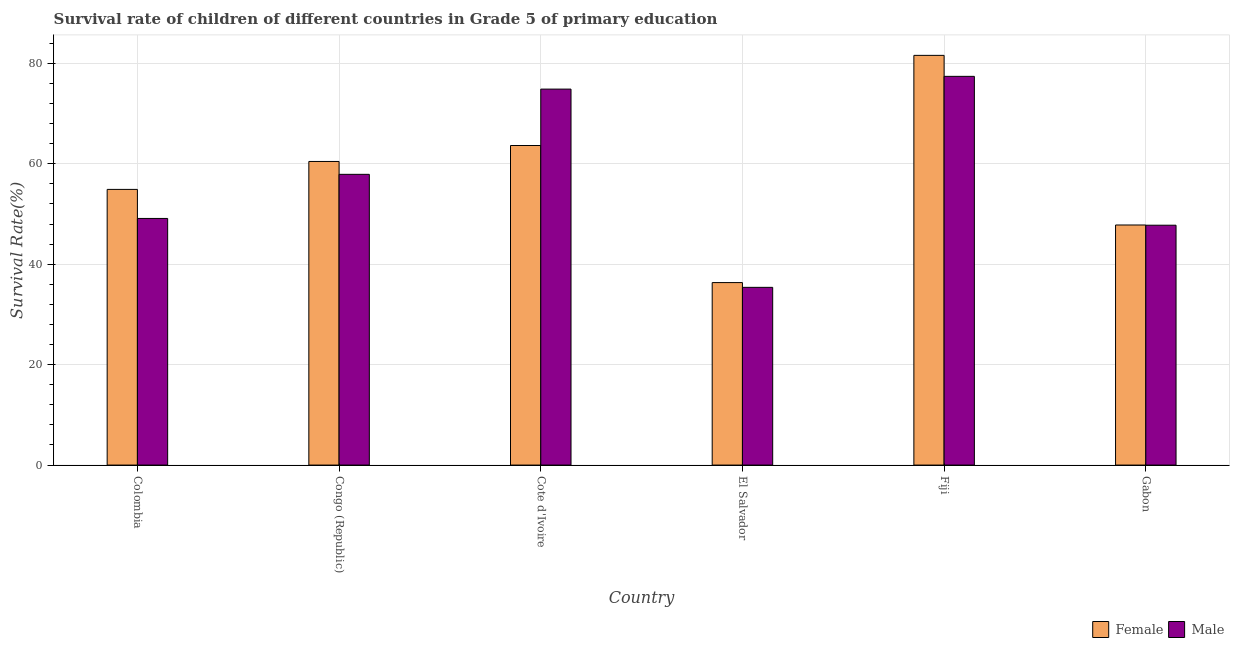How many groups of bars are there?
Provide a succinct answer. 6. Are the number of bars on each tick of the X-axis equal?
Make the answer very short. Yes. How many bars are there on the 4th tick from the left?
Ensure brevity in your answer.  2. What is the label of the 2nd group of bars from the left?
Your response must be concise. Congo (Republic). What is the survival rate of female students in primary education in Fiji?
Your answer should be very brief. 81.6. Across all countries, what is the maximum survival rate of female students in primary education?
Provide a succinct answer. 81.6. Across all countries, what is the minimum survival rate of female students in primary education?
Give a very brief answer. 36.35. In which country was the survival rate of male students in primary education maximum?
Your response must be concise. Fiji. In which country was the survival rate of female students in primary education minimum?
Your answer should be very brief. El Salvador. What is the total survival rate of male students in primary education in the graph?
Your response must be concise. 342.5. What is the difference between the survival rate of female students in primary education in Congo (Republic) and that in El Salvador?
Provide a short and direct response. 24.12. What is the difference between the survival rate of female students in primary education in Fiji and the survival rate of male students in primary education in Colombia?
Your response must be concise. 32.48. What is the average survival rate of male students in primary education per country?
Your response must be concise. 57.08. What is the difference between the survival rate of male students in primary education and survival rate of female students in primary education in Gabon?
Make the answer very short. -0.04. What is the ratio of the survival rate of female students in primary education in El Salvador to that in Fiji?
Keep it short and to the point. 0.45. Is the survival rate of male students in primary education in El Salvador less than that in Fiji?
Provide a short and direct response. Yes. What is the difference between the highest and the second highest survival rate of female students in primary education?
Your answer should be very brief. 17.96. What is the difference between the highest and the lowest survival rate of male students in primary education?
Provide a succinct answer. 42.02. Is the sum of the survival rate of male students in primary education in El Salvador and Gabon greater than the maximum survival rate of female students in primary education across all countries?
Your response must be concise. Yes. What does the 1st bar from the right in Gabon represents?
Your response must be concise. Male. How many bars are there?
Keep it short and to the point. 12. Are all the bars in the graph horizontal?
Keep it short and to the point. No. How many countries are there in the graph?
Give a very brief answer. 6. Are the values on the major ticks of Y-axis written in scientific E-notation?
Provide a succinct answer. No. Where does the legend appear in the graph?
Offer a terse response. Bottom right. How many legend labels are there?
Keep it short and to the point. 2. What is the title of the graph?
Ensure brevity in your answer.  Survival rate of children of different countries in Grade 5 of primary education. Does "RDB concessional" appear as one of the legend labels in the graph?
Offer a terse response. No. What is the label or title of the X-axis?
Your answer should be compact. Country. What is the label or title of the Y-axis?
Offer a very short reply. Survival Rate(%). What is the Survival Rate(%) of Female in Colombia?
Provide a succinct answer. 54.91. What is the Survival Rate(%) of Male in Colombia?
Give a very brief answer. 49.12. What is the Survival Rate(%) of Female in Congo (Republic)?
Your answer should be compact. 60.47. What is the Survival Rate(%) in Male in Congo (Republic)?
Your answer should be compact. 57.91. What is the Survival Rate(%) of Female in Cote d'Ivoire?
Keep it short and to the point. 63.65. What is the Survival Rate(%) in Male in Cote d'Ivoire?
Keep it short and to the point. 74.88. What is the Survival Rate(%) of Female in El Salvador?
Provide a short and direct response. 36.35. What is the Survival Rate(%) of Male in El Salvador?
Offer a terse response. 35.4. What is the Survival Rate(%) in Female in Fiji?
Your answer should be very brief. 81.6. What is the Survival Rate(%) of Male in Fiji?
Provide a short and direct response. 77.42. What is the Survival Rate(%) in Female in Gabon?
Your answer should be very brief. 47.82. What is the Survival Rate(%) of Male in Gabon?
Your response must be concise. 47.77. Across all countries, what is the maximum Survival Rate(%) in Female?
Your answer should be compact. 81.6. Across all countries, what is the maximum Survival Rate(%) in Male?
Your answer should be compact. 77.42. Across all countries, what is the minimum Survival Rate(%) in Female?
Provide a short and direct response. 36.35. Across all countries, what is the minimum Survival Rate(%) in Male?
Provide a succinct answer. 35.4. What is the total Survival Rate(%) of Female in the graph?
Provide a succinct answer. 344.79. What is the total Survival Rate(%) of Male in the graph?
Provide a short and direct response. 342.5. What is the difference between the Survival Rate(%) of Female in Colombia and that in Congo (Republic)?
Give a very brief answer. -5.56. What is the difference between the Survival Rate(%) in Male in Colombia and that in Congo (Republic)?
Provide a succinct answer. -8.79. What is the difference between the Survival Rate(%) in Female in Colombia and that in Cote d'Ivoire?
Make the answer very short. -8.74. What is the difference between the Survival Rate(%) in Male in Colombia and that in Cote d'Ivoire?
Your answer should be very brief. -25.76. What is the difference between the Survival Rate(%) of Female in Colombia and that in El Salvador?
Offer a very short reply. 18.56. What is the difference between the Survival Rate(%) of Male in Colombia and that in El Salvador?
Ensure brevity in your answer.  13.72. What is the difference between the Survival Rate(%) of Female in Colombia and that in Fiji?
Your answer should be very brief. -26.69. What is the difference between the Survival Rate(%) of Male in Colombia and that in Fiji?
Your answer should be compact. -28.3. What is the difference between the Survival Rate(%) in Female in Colombia and that in Gabon?
Your answer should be very brief. 7.09. What is the difference between the Survival Rate(%) in Male in Colombia and that in Gabon?
Provide a succinct answer. 1.35. What is the difference between the Survival Rate(%) of Female in Congo (Republic) and that in Cote d'Ivoire?
Provide a short and direct response. -3.18. What is the difference between the Survival Rate(%) in Male in Congo (Republic) and that in Cote d'Ivoire?
Provide a short and direct response. -16.97. What is the difference between the Survival Rate(%) in Female in Congo (Republic) and that in El Salvador?
Provide a short and direct response. 24.12. What is the difference between the Survival Rate(%) in Male in Congo (Republic) and that in El Salvador?
Your answer should be very brief. 22.51. What is the difference between the Survival Rate(%) in Female in Congo (Republic) and that in Fiji?
Your answer should be very brief. -21.13. What is the difference between the Survival Rate(%) of Male in Congo (Republic) and that in Fiji?
Offer a very short reply. -19.51. What is the difference between the Survival Rate(%) in Female in Congo (Republic) and that in Gabon?
Provide a short and direct response. 12.65. What is the difference between the Survival Rate(%) in Male in Congo (Republic) and that in Gabon?
Provide a succinct answer. 10.14. What is the difference between the Survival Rate(%) of Female in Cote d'Ivoire and that in El Salvador?
Your answer should be compact. 27.3. What is the difference between the Survival Rate(%) in Male in Cote d'Ivoire and that in El Salvador?
Offer a terse response. 39.48. What is the difference between the Survival Rate(%) in Female in Cote d'Ivoire and that in Fiji?
Make the answer very short. -17.96. What is the difference between the Survival Rate(%) in Male in Cote d'Ivoire and that in Fiji?
Offer a terse response. -2.54. What is the difference between the Survival Rate(%) of Female in Cote d'Ivoire and that in Gabon?
Your answer should be very brief. 15.83. What is the difference between the Survival Rate(%) of Male in Cote d'Ivoire and that in Gabon?
Ensure brevity in your answer.  27.11. What is the difference between the Survival Rate(%) of Female in El Salvador and that in Fiji?
Keep it short and to the point. -45.26. What is the difference between the Survival Rate(%) of Male in El Salvador and that in Fiji?
Offer a terse response. -42.02. What is the difference between the Survival Rate(%) of Female in El Salvador and that in Gabon?
Offer a terse response. -11.47. What is the difference between the Survival Rate(%) of Male in El Salvador and that in Gabon?
Your answer should be compact. -12.37. What is the difference between the Survival Rate(%) of Female in Fiji and that in Gabon?
Make the answer very short. 33.79. What is the difference between the Survival Rate(%) in Male in Fiji and that in Gabon?
Your answer should be very brief. 29.65. What is the difference between the Survival Rate(%) in Female in Colombia and the Survival Rate(%) in Male in Congo (Republic)?
Your answer should be compact. -3. What is the difference between the Survival Rate(%) of Female in Colombia and the Survival Rate(%) of Male in Cote d'Ivoire?
Give a very brief answer. -19.97. What is the difference between the Survival Rate(%) of Female in Colombia and the Survival Rate(%) of Male in El Salvador?
Ensure brevity in your answer.  19.51. What is the difference between the Survival Rate(%) in Female in Colombia and the Survival Rate(%) in Male in Fiji?
Ensure brevity in your answer.  -22.51. What is the difference between the Survival Rate(%) in Female in Colombia and the Survival Rate(%) in Male in Gabon?
Keep it short and to the point. 7.14. What is the difference between the Survival Rate(%) in Female in Congo (Republic) and the Survival Rate(%) in Male in Cote d'Ivoire?
Your answer should be very brief. -14.41. What is the difference between the Survival Rate(%) in Female in Congo (Republic) and the Survival Rate(%) in Male in El Salvador?
Your answer should be very brief. 25.07. What is the difference between the Survival Rate(%) in Female in Congo (Republic) and the Survival Rate(%) in Male in Fiji?
Keep it short and to the point. -16.95. What is the difference between the Survival Rate(%) of Female in Congo (Republic) and the Survival Rate(%) of Male in Gabon?
Provide a succinct answer. 12.7. What is the difference between the Survival Rate(%) of Female in Cote d'Ivoire and the Survival Rate(%) of Male in El Salvador?
Give a very brief answer. 28.25. What is the difference between the Survival Rate(%) in Female in Cote d'Ivoire and the Survival Rate(%) in Male in Fiji?
Offer a terse response. -13.78. What is the difference between the Survival Rate(%) of Female in Cote d'Ivoire and the Survival Rate(%) of Male in Gabon?
Keep it short and to the point. 15.87. What is the difference between the Survival Rate(%) of Female in El Salvador and the Survival Rate(%) of Male in Fiji?
Your answer should be very brief. -41.08. What is the difference between the Survival Rate(%) in Female in El Salvador and the Survival Rate(%) in Male in Gabon?
Ensure brevity in your answer.  -11.43. What is the difference between the Survival Rate(%) of Female in Fiji and the Survival Rate(%) of Male in Gabon?
Offer a terse response. 33.83. What is the average Survival Rate(%) in Female per country?
Your answer should be compact. 57.46. What is the average Survival Rate(%) in Male per country?
Your answer should be very brief. 57.08. What is the difference between the Survival Rate(%) of Female and Survival Rate(%) of Male in Colombia?
Ensure brevity in your answer.  5.79. What is the difference between the Survival Rate(%) of Female and Survival Rate(%) of Male in Congo (Republic)?
Provide a succinct answer. 2.56. What is the difference between the Survival Rate(%) of Female and Survival Rate(%) of Male in Cote d'Ivoire?
Provide a succinct answer. -11.24. What is the difference between the Survival Rate(%) of Female and Survival Rate(%) of Male in El Salvador?
Your answer should be very brief. 0.95. What is the difference between the Survival Rate(%) of Female and Survival Rate(%) of Male in Fiji?
Provide a succinct answer. 4.18. What is the difference between the Survival Rate(%) of Female and Survival Rate(%) of Male in Gabon?
Provide a short and direct response. 0.04. What is the ratio of the Survival Rate(%) in Female in Colombia to that in Congo (Republic)?
Your answer should be compact. 0.91. What is the ratio of the Survival Rate(%) of Male in Colombia to that in Congo (Republic)?
Give a very brief answer. 0.85. What is the ratio of the Survival Rate(%) of Female in Colombia to that in Cote d'Ivoire?
Provide a short and direct response. 0.86. What is the ratio of the Survival Rate(%) in Male in Colombia to that in Cote d'Ivoire?
Offer a terse response. 0.66. What is the ratio of the Survival Rate(%) in Female in Colombia to that in El Salvador?
Offer a terse response. 1.51. What is the ratio of the Survival Rate(%) in Male in Colombia to that in El Salvador?
Offer a terse response. 1.39. What is the ratio of the Survival Rate(%) in Female in Colombia to that in Fiji?
Provide a short and direct response. 0.67. What is the ratio of the Survival Rate(%) of Male in Colombia to that in Fiji?
Make the answer very short. 0.63. What is the ratio of the Survival Rate(%) in Female in Colombia to that in Gabon?
Provide a short and direct response. 1.15. What is the ratio of the Survival Rate(%) of Male in Colombia to that in Gabon?
Make the answer very short. 1.03. What is the ratio of the Survival Rate(%) of Female in Congo (Republic) to that in Cote d'Ivoire?
Offer a terse response. 0.95. What is the ratio of the Survival Rate(%) of Male in Congo (Republic) to that in Cote d'Ivoire?
Provide a short and direct response. 0.77. What is the ratio of the Survival Rate(%) of Female in Congo (Republic) to that in El Salvador?
Offer a terse response. 1.66. What is the ratio of the Survival Rate(%) of Male in Congo (Republic) to that in El Salvador?
Offer a terse response. 1.64. What is the ratio of the Survival Rate(%) in Female in Congo (Republic) to that in Fiji?
Offer a terse response. 0.74. What is the ratio of the Survival Rate(%) in Male in Congo (Republic) to that in Fiji?
Ensure brevity in your answer.  0.75. What is the ratio of the Survival Rate(%) in Female in Congo (Republic) to that in Gabon?
Make the answer very short. 1.26. What is the ratio of the Survival Rate(%) in Male in Congo (Republic) to that in Gabon?
Make the answer very short. 1.21. What is the ratio of the Survival Rate(%) of Female in Cote d'Ivoire to that in El Salvador?
Offer a very short reply. 1.75. What is the ratio of the Survival Rate(%) of Male in Cote d'Ivoire to that in El Salvador?
Give a very brief answer. 2.12. What is the ratio of the Survival Rate(%) of Female in Cote d'Ivoire to that in Fiji?
Offer a very short reply. 0.78. What is the ratio of the Survival Rate(%) of Male in Cote d'Ivoire to that in Fiji?
Offer a terse response. 0.97. What is the ratio of the Survival Rate(%) in Female in Cote d'Ivoire to that in Gabon?
Ensure brevity in your answer.  1.33. What is the ratio of the Survival Rate(%) in Male in Cote d'Ivoire to that in Gabon?
Your response must be concise. 1.57. What is the ratio of the Survival Rate(%) of Female in El Salvador to that in Fiji?
Ensure brevity in your answer.  0.45. What is the ratio of the Survival Rate(%) in Male in El Salvador to that in Fiji?
Provide a short and direct response. 0.46. What is the ratio of the Survival Rate(%) in Female in El Salvador to that in Gabon?
Your response must be concise. 0.76. What is the ratio of the Survival Rate(%) in Male in El Salvador to that in Gabon?
Keep it short and to the point. 0.74. What is the ratio of the Survival Rate(%) in Female in Fiji to that in Gabon?
Ensure brevity in your answer.  1.71. What is the ratio of the Survival Rate(%) of Male in Fiji to that in Gabon?
Ensure brevity in your answer.  1.62. What is the difference between the highest and the second highest Survival Rate(%) of Female?
Your answer should be compact. 17.96. What is the difference between the highest and the second highest Survival Rate(%) in Male?
Ensure brevity in your answer.  2.54. What is the difference between the highest and the lowest Survival Rate(%) in Female?
Offer a very short reply. 45.26. What is the difference between the highest and the lowest Survival Rate(%) in Male?
Provide a short and direct response. 42.02. 